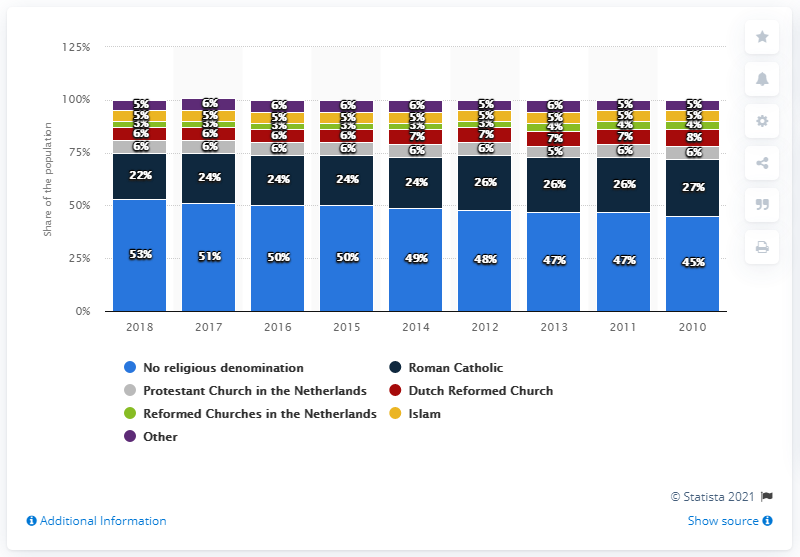Identify some key points in this picture. In 2018, 22% of the Dutch population identified as Roman Catholic. 